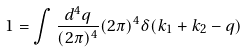<formula> <loc_0><loc_0><loc_500><loc_500>1 = \int \frac { d ^ { 4 } q } { ( 2 \pi ) ^ { 4 } } ( 2 \pi ) ^ { 4 } \delta ( k _ { 1 } + k _ { 2 } - q )</formula> 